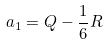<formula> <loc_0><loc_0><loc_500><loc_500>a _ { 1 } = Q - \frac { 1 } { 6 } R</formula> 